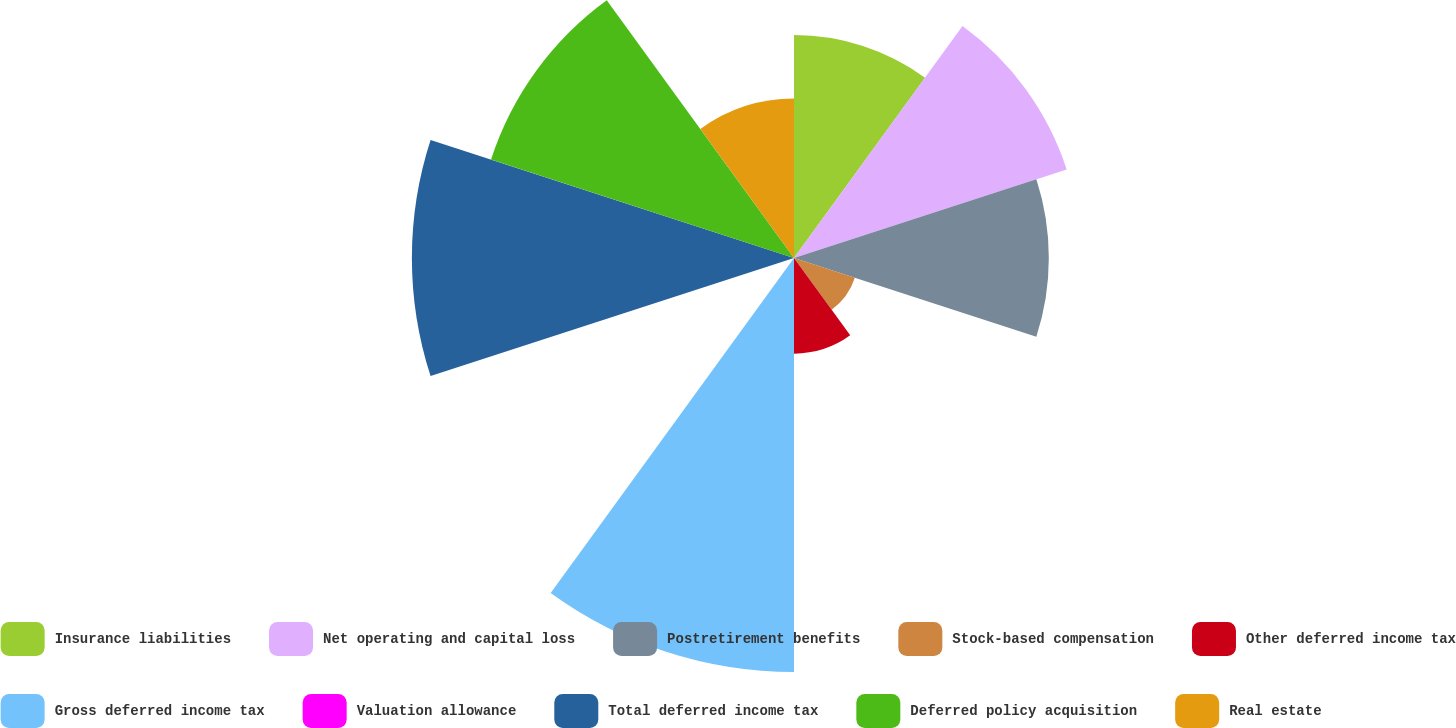<chart> <loc_0><loc_0><loc_500><loc_500><pie_chart><fcel>Insurance liabilities<fcel>Net operating and capital loss<fcel>Postretirement benefits<fcel>Stock-based compensation<fcel>Other deferred income tax<fcel>Gross deferred income tax<fcel>Valuation allowance<fcel>Total deferred income tax<fcel>Deferred policy acquisition<fcel>Real estate<nl><fcel>10.14%<fcel>13.04%<fcel>11.59%<fcel>2.91%<fcel>4.35%<fcel>18.83%<fcel>0.01%<fcel>17.38%<fcel>14.49%<fcel>7.25%<nl></chart> 